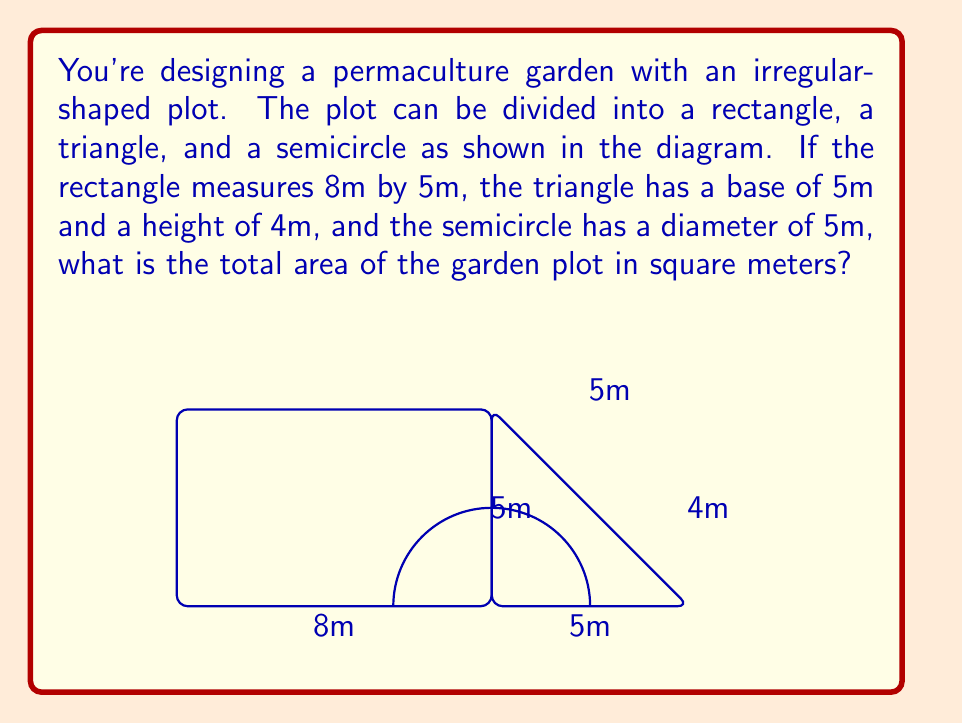What is the answer to this math problem? To calculate the total area, we need to sum the areas of the rectangle, triangle, and semicircle:

1. Area of rectangle:
   $A_r = l \times w = 8 \text{ m} \times 5 \text{ m} = 40 \text{ m}^2$

2. Area of triangle:
   $A_t = \frac{1}{2} \times b \times h = \frac{1}{2} \times 5 \text{ m} \times 4 \text{ m} = 10 \text{ m}^2$

3. Area of semicircle:
   First, calculate the radius: $r = \frac{diameter}{2} = \frac{5 \text{ m}}{2} = 2.5 \text{ m}$
   Then, use the formula for the area of a semicircle:
   $A_s = \frac{1}{2} \times \pi r^2 = \frac{1}{2} \times \pi \times (2.5 \text{ m})^2 \approx 9.82 \text{ m}^2$

4. Total area:
   $A_{total} = A_r + A_t + A_s = 40 \text{ m}^2 + 10 \text{ m}^2 + 9.82 \text{ m}^2 = 59.82 \text{ m}^2$

Rounding to two decimal places, the total area is 59.82 m².
Answer: 59.82 m² 